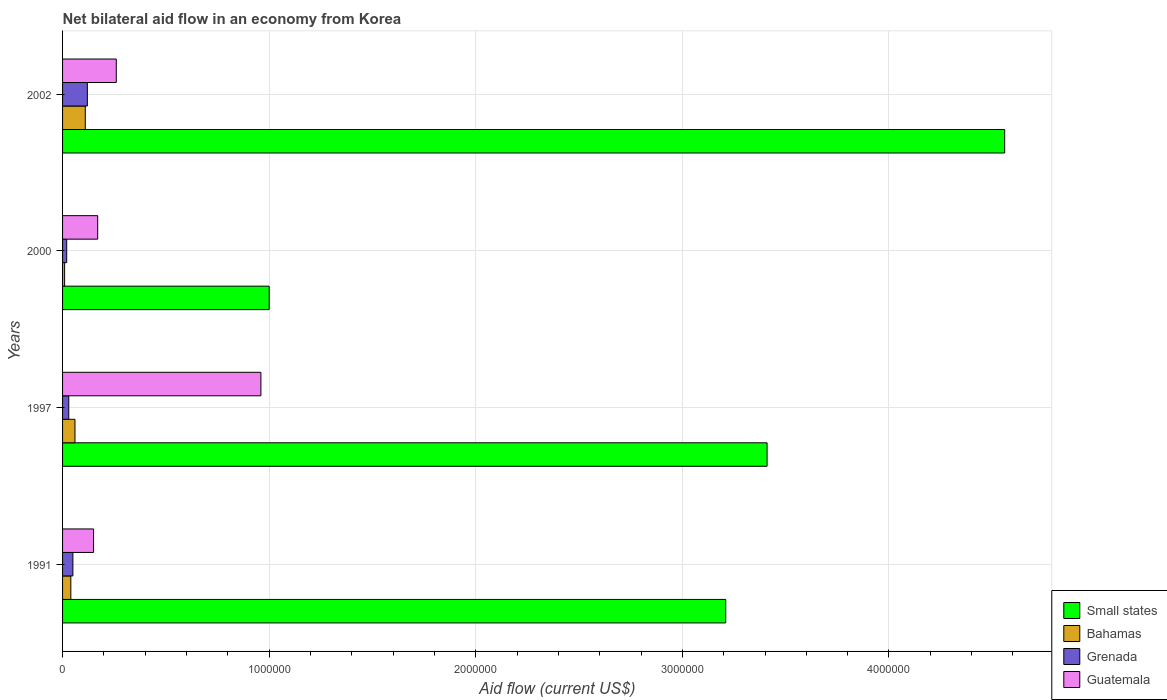How many different coloured bars are there?
Your response must be concise. 4. How many groups of bars are there?
Offer a very short reply. 4. Are the number of bars per tick equal to the number of legend labels?
Your answer should be very brief. Yes. In how many cases, is the number of bars for a given year not equal to the number of legend labels?
Your answer should be very brief. 0. Across all years, what is the maximum net bilateral aid flow in Guatemala?
Make the answer very short. 9.60e+05. In which year was the net bilateral aid flow in Guatemala maximum?
Offer a terse response. 1997. What is the total net bilateral aid flow in Guatemala in the graph?
Ensure brevity in your answer.  1.54e+06. What is the difference between the net bilateral aid flow in Guatemala in 2000 and that in 2002?
Keep it short and to the point. -9.00e+04. What is the difference between the net bilateral aid flow in Small states in 1997 and the net bilateral aid flow in Grenada in 2002?
Ensure brevity in your answer.  3.29e+06. What is the average net bilateral aid flow in Grenada per year?
Keep it short and to the point. 5.50e+04. In the year 2000, what is the difference between the net bilateral aid flow in Guatemala and net bilateral aid flow in Small states?
Keep it short and to the point. -8.30e+05. What is the ratio of the net bilateral aid flow in Small states in 1997 to that in 2000?
Provide a short and direct response. 3.41. What is the difference between the highest and the second highest net bilateral aid flow in Bahamas?
Offer a very short reply. 5.00e+04. What is the difference between the highest and the lowest net bilateral aid flow in Guatemala?
Your answer should be compact. 8.10e+05. Is the sum of the net bilateral aid flow in Grenada in 2000 and 2002 greater than the maximum net bilateral aid flow in Small states across all years?
Make the answer very short. No. What does the 4th bar from the top in 1991 represents?
Give a very brief answer. Small states. What does the 1st bar from the bottom in 1997 represents?
Offer a very short reply. Small states. Are all the bars in the graph horizontal?
Your answer should be very brief. Yes. How many years are there in the graph?
Offer a terse response. 4. What is the difference between two consecutive major ticks on the X-axis?
Ensure brevity in your answer.  1.00e+06. Are the values on the major ticks of X-axis written in scientific E-notation?
Provide a short and direct response. No. Does the graph contain grids?
Keep it short and to the point. Yes. Where does the legend appear in the graph?
Your answer should be compact. Bottom right. How many legend labels are there?
Keep it short and to the point. 4. How are the legend labels stacked?
Your answer should be compact. Vertical. What is the title of the graph?
Your answer should be compact. Net bilateral aid flow in an economy from Korea. What is the label or title of the Y-axis?
Give a very brief answer. Years. What is the Aid flow (current US$) in Small states in 1991?
Your response must be concise. 3.21e+06. What is the Aid flow (current US$) of Guatemala in 1991?
Keep it short and to the point. 1.50e+05. What is the Aid flow (current US$) of Small states in 1997?
Provide a short and direct response. 3.41e+06. What is the Aid flow (current US$) in Guatemala in 1997?
Provide a short and direct response. 9.60e+05. What is the Aid flow (current US$) of Small states in 2000?
Your answer should be very brief. 1.00e+06. What is the Aid flow (current US$) in Bahamas in 2000?
Keep it short and to the point. 10000. What is the Aid flow (current US$) of Guatemala in 2000?
Keep it short and to the point. 1.70e+05. What is the Aid flow (current US$) of Small states in 2002?
Provide a succinct answer. 4.56e+06. What is the Aid flow (current US$) in Grenada in 2002?
Provide a short and direct response. 1.20e+05. Across all years, what is the maximum Aid flow (current US$) of Small states?
Your response must be concise. 4.56e+06. Across all years, what is the maximum Aid flow (current US$) in Bahamas?
Ensure brevity in your answer.  1.10e+05. Across all years, what is the maximum Aid flow (current US$) of Guatemala?
Your answer should be very brief. 9.60e+05. Across all years, what is the minimum Aid flow (current US$) in Small states?
Provide a short and direct response. 1.00e+06. Across all years, what is the minimum Aid flow (current US$) of Bahamas?
Your response must be concise. 10000. Across all years, what is the minimum Aid flow (current US$) in Grenada?
Make the answer very short. 2.00e+04. Across all years, what is the minimum Aid flow (current US$) in Guatemala?
Keep it short and to the point. 1.50e+05. What is the total Aid flow (current US$) in Small states in the graph?
Provide a short and direct response. 1.22e+07. What is the total Aid flow (current US$) in Bahamas in the graph?
Your answer should be compact. 2.20e+05. What is the total Aid flow (current US$) in Grenada in the graph?
Make the answer very short. 2.20e+05. What is the total Aid flow (current US$) of Guatemala in the graph?
Make the answer very short. 1.54e+06. What is the difference between the Aid flow (current US$) of Bahamas in 1991 and that in 1997?
Provide a succinct answer. -2.00e+04. What is the difference between the Aid flow (current US$) of Grenada in 1991 and that in 1997?
Make the answer very short. 2.00e+04. What is the difference between the Aid flow (current US$) of Guatemala in 1991 and that in 1997?
Offer a terse response. -8.10e+05. What is the difference between the Aid flow (current US$) in Small states in 1991 and that in 2000?
Keep it short and to the point. 2.21e+06. What is the difference between the Aid flow (current US$) of Bahamas in 1991 and that in 2000?
Keep it short and to the point. 3.00e+04. What is the difference between the Aid flow (current US$) of Small states in 1991 and that in 2002?
Make the answer very short. -1.35e+06. What is the difference between the Aid flow (current US$) of Bahamas in 1991 and that in 2002?
Keep it short and to the point. -7.00e+04. What is the difference between the Aid flow (current US$) of Grenada in 1991 and that in 2002?
Give a very brief answer. -7.00e+04. What is the difference between the Aid flow (current US$) of Guatemala in 1991 and that in 2002?
Provide a short and direct response. -1.10e+05. What is the difference between the Aid flow (current US$) in Small states in 1997 and that in 2000?
Offer a terse response. 2.41e+06. What is the difference between the Aid flow (current US$) in Guatemala in 1997 and that in 2000?
Provide a short and direct response. 7.90e+05. What is the difference between the Aid flow (current US$) of Small states in 1997 and that in 2002?
Your answer should be very brief. -1.15e+06. What is the difference between the Aid flow (current US$) in Small states in 2000 and that in 2002?
Your answer should be very brief. -3.56e+06. What is the difference between the Aid flow (current US$) in Grenada in 2000 and that in 2002?
Provide a succinct answer. -1.00e+05. What is the difference between the Aid flow (current US$) of Guatemala in 2000 and that in 2002?
Your response must be concise. -9.00e+04. What is the difference between the Aid flow (current US$) in Small states in 1991 and the Aid flow (current US$) in Bahamas in 1997?
Keep it short and to the point. 3.15e+06. What is the difference between the Aid flow (current US$) in Small states in 1991 and the Aid flow (current US$) in Grenada in 1997?
Provide a succinct answer. 3.18e+06. What is the difference between the Aid flow (current US$) of Small states in 1991 and the Aid flow (current US$) of Guatemala in 1997?
Your response must be concise. 2.25e+06. What is the difference between the Aid flow (current US$) of Bahamas in 1991 and the Aid flow (current US$) of Grenada in 1997?
Make the answer very short. 10000. What is the difference between the Aid flow (current US$) of Bahamas in 1991 and the Aid flow (current US$) of Guatemala in 1997?
Your response must be concise. -9.20e+05. What is the difference between the Aid flow (current US$) in Grenada in 1991 and the Aid flow (current US$) in Guatemala in 1997?
Ensure brevity in your answer.  -9.10e+05. What is the difference between the Aid flow (current US$) in Small states in 1991 and the Aid flow (current US$) in Bahamas in 2000?
Your response must be concise. 3.20e+06. What is the difference between the Aid flow (current US$) in Small states in 1991 and the Aid flow (current US$) in Grenada in 2000?
Your response must be concise. 3.19e+06. What is the difference between the Aid flow (current US$) of Small states in 1991 and the Aid flow (current US$) of Guatemala in 2000?
Your response must be concise. 3.04e+06. What is the difference between the Aid flow (current US$) in Bahamas in 1991 and the Aid flow (current US$) in Grenada in 2000?
Provide a short and direct response. 2.00e+04. What is the difference between the Aid flow (current US$) in Grenada in 1991 and the Aid flow (current US$) in Guatemala in 2000?
Your answer should be compact. -1.20e+05. What is the difference between the Aid flow (current US$) in Small states in 1991 and the Aid flow (current US$) in Bahamas in 2002?
Offer a very short reply. 3.10e+06. What is the difference between the Aid flow (current US$) of Small states in 1991 and the Aid flow (current US$) of Grenada in 2002?
Your answer should be very brief. 3.09e+06. What is the difference between the Aid flow (current US$) in Small states in 1991 and the Aid flow (current US$) in Guatemala in 2002?
Your answer should be very brief. 2.95e+06. What is the difference between the Aid flow (current US$) in Bahamas in 1991 and the Aid flow (current US$) in Grenada in 2002?
Provide a short and direct response. -8.00e+04. What is the difference between the Aid flow (current US$) of Bahamas in 1991 and the Aid flow (current US$) of Guatemala in 2002?
Provide a succinct answer. -2.20e+05. What is the difference between the Aid flow (current US$) in Grenada in 1991 and the Aid flow (current US$) in Guatemala in 2002?
Make the answer very short. -2.10e+05. What is the difference between the Aid flow (current US$) in Small states in 1997 and the Aid flow (current US$) in Bahamas in 2000?
Offer a terse response. 3.40e+06. What is the difference between the Aid flow (current US$) of Small states in 1997 and the Aid flow (current US$) of Grenada in 2000?
Offer a terse response. 3.39e+06. What is the difference between the Aid flow (current US$) of Small states in 1997 and the Aid flow (current US$) of Guatemala in 2000?
Provide a short and direct response. 3.24e+06. What is the difference between the Aid flow (current US$) in Bahamas in 1997 and the Aid flow (current US$) in Grenada in 2000?
Make the answer very short. 4.00e+04. What is the difference between the Aid flow (current US$) in Bahamas in 1997 and the Aid flow (current US$) in Guatemala in 2000?
Your answer should be very brief. -1.10e+05. What is the difference between the Aid flow (current US$) of Small states in 1997 and the Aid flow (current US$) of Bahamas in 2002?
Keep it short and to the point. 3.30e+06. What is the difference between the Aid flow (current US$) of Small states in 1997 and the Aid flow (current US$) of Grenada in 2002?
Your answer should be very brief. 3.29e+06. What is the difference between the Aid flow (current US$) of Small states in 1997 and the Aid flow (current US$) of Guatemala in 2002?
Offer a terse response. 3.15e+06. What is the difference between the Aid flow (current US$) of Bahamas in 1997 and the Aid flow (current US$) of Grenada in 2002?
Your answer should be compact. -6.00e+04. What is the difference between the Aid flow (current US$) of Bahamas in 1997 and the Aid flow (current US$) of Guatemala in 2002?
Offer a very short reply. -2.00e+05. What is the difference between the Aid flow (current US$) in Small states in 2000 and the Aid flow (current US$) in Bahamas in 2002?
Your response must be concise. 8.90e+05. What is the difference between the Aid flow (current US$) in Small states in 2000 and the Aid flow (current US$) in Grenada in 2002?
Your answer should be compact. 8.80e+05. What is the difference between the Aid flow (current US$) of Small states in 2000 and the Aid flow (current US$) of Guatemala in 2002?
Make the answer very short. 7.40e+05. What is the difference between the Aid flow (current US$) of Bahamas in 2000 and the Aid flow (current US$) of Guatemala in 2002?
Provide a succinct answer. -2.50e+05. What is the average Aid flow (current US$) in Small states per year?
Your response must be concise. 3.04e+06. What is the average Aid flow (current US$) of Bahamas per year?
Offer a very short reply. 5.50e+04. What is the average Aid flow (current US$) of Grenada per year?
Your answer should be compact. 5.50e+04. What is the average Aid flow (current US$) of Guatemala per year?
Offer a very short reply. 3.85e+05. In the year 1991, what is the difference between the Aid flow (current US$) in Small states and Aid flow (current US$) in Bahamas?
Your answer should be very brief. 3.17e+06. In the year 1991, what is the difference between the Aid flow (current US$) in Small states and Aid flow (current US$) in Grenada?
Offer a very short reply. 3.16e+06. In the year 1991, what is the difference between the Aid flow (current US$) of Small states and Aid flow (current US$) of Guatemala?
Provide a short and direct response. 3.06e+06. In the year 1991, what is the difference between the Aid flow (current US$) in Bahamas and Aid flow (current US$) in Grenada?
Your answer should be compact. -10000. In the year 1997, what is the difference between the Aid flow (current US$) in Small states and Aid flow (current US$) in Bahamas?
Provide a succinct answer. 3.35e+06. In the year 1997, what is the difference between the Aid flow (current US$) in Small states and Aid flow (current US$) in Grenada?
Your answer should be compact. 3.38e+06. In the year 1997, what is the difference between the Aid flow (current US$) in Small states and Aid flow (current US$) in Guatemala?
Give a very brief answer. 2.45e+06. In the year 1997, what is the difference between the Aid flow (current US$) in Bahamas and Aid flow (current US$) in Grenada?
Your answer should be compact. 3.00e+04. In the year 1997, what is the difference between the Aid flow (current US$) of Bahamas and Aid flow (current US$) of Guatemala?
Offer a terse response. -9.00e+05. In the year 1997, what is the difference between the Aid flow (current US$) in Grenada and Aid flow (current US$) in Guatemala?
Provide a succinct answer. -9.30e+05. In the year 2000, what is the difference between the Aid flow (current US$) of Small states and Aid flow (current US$) of Bahamas?
Provide a short and direct response. 9.90e+05. In the year 2000, what is the difference between the Aid flow (current US$) of Small states and Aid flow (current US$) of Grenada?
Your answer should be very brief. 9.80e+05. In the year 2000, what is the difference between the Aid flow (current US$) in Small states and Aid flow (current US$) in Guatemala?
Make the answer very short. 8.30e+05. In the year 2000, what is the difference between the Aid flow (current US$) in Bahamas and Aid flow (current US$) in Grenada?
Your answer should be compact. -10000. In the year 2000, what is the difference between the Aid flow (current US$) in Bahamas and Aid flow (current US$) in Guatemala?
Provide a short and direct response. -1.60e+05. In the year 2002, what is the difference between the Aid flow (current US$) of Small states and Aid flow (current US$) of Bahamas?
Offer a terse response. 4.45e+06. In the year 2002, what is the difference between the Aid flow (current US$) in Small states and Aid flow (current US$) in Grenada?
Offer a terse response. 4.44e+06. In the year 2002, what is the difference between the Aid flow (current US$) of Small states and Aid flow (current US$) of Guatemala?
Provide a short and direct response. 4.30e+06. In the year 2002, what is the difference between the Aid flow (current US$) of Grenada and Aid flow (current US$) of Guatemala?
Keep it short and to the point. -1.40e+05. What is the ratio of the Aid flow (current US$) of Small states in 1991 to that in 1997?
Your response must be concise. 0.94. What is the ratio of the Aid flow (current US$) in Bahamas in 1991 to that in 1997?
Provide a succinct answer. 0.67. What is the ratio of the Aid flow (current US$) of Guatemala in 1991 to that in 1997?
Your response must be concise. 0.16. What is the ratio of the Aid flow (current US$) of Small states in 1991 to that in 2000?
Make the answer very short. 3.21. What is the ratio of the Aid flow (current US$) in Grenada in 1991 to that in 2000?
Make the answer very short. 2.5. What is the ratio of the Aid flow (current US$) in Guatemala in 1991 to that in 2000?
Provide a short and direct response. 0.88. What is the ratio of the Aid flow (current US$) in Small states in 1991 to that in 2002?
Ensure brevity in your answer.  0.7. What is the ratio of the Aid flow (current US$) of Bahamas in 1991 to that in 2002?
Your response must be concise. 0.36. What is the ratio of the Aid flow (current US$) in Grenada in 1991 to that in 2002?
Provide a short and direct response. 0.42. What is the ratio of the Aid flow (current US$) of Guatemala in 1991 to that in 2002?
Your answer should be compact. 0.58. What is the ratio of the Aid flow (current US$) in Small states in 1997 to that in 2000?
Keep it short and to the point. 3.41. What is the ratio of the Aid flow (current US$) of Bahamas in 1997 to that in 2000?
Give a very brief answer. 6. What is the ratio of the Aid flow (current US$) of Grenada in 1997 to that in 2000?
Provide a short and direct response. 1.5. What is the ratio of the Aid flow (current US$) of Guatemala in 1997 to that in 2000?
Offer a very short reply. 5.65. What is the ratio of the Aid flow (current US$) of Small states in 1997 to that in 2002?
Your response must be concise. 0.75. What is the ratio of the Aid flow (current US$) in Bahamas in 1997 to that in 2002?
Give a very brief answer. 0.55. What is the ratio of the Aid flow (current US$) in Guatemala in 1997 to that in 2002?
Your answer should be compact. 3.69. What is the ratio of the Aid flow (current US$) of Small states in 2000 to that in 2002?
Your response must be concise. 0.22. What is the ratio of the Aid flow (current US$) of Bahamas in 2000 to that in 2002?
Your response must be concise. 0.09. What is the ratio of the Aid flow (current US$) in Guatemala in 2000 to that in 2002?
Your response must be concise. 0.65. What is the difference between the highest and the second highest Aid flow (current US$) in Small states?
Keep it short and to the point. 1.15e+06. What is the difference between the highest and the second highest Aid flow (current US$) of Grenada?
Offer a very short reply. 7.00e+04. What is the difference between the highest and the second highest Aid flow (current US$) of Guatemala?
Your answer should be very brief. 7.00e+05. What is the difference between the highest and the lowest Aid flow (current US$) of Small states?
Your answer should be compact. 3.56e+06. What is the difference between the highest and the lowest Aid flow (current US$) of Bahamas?
Offer a terse response. 1.00e+05. What is the difference between the highest and the lowest Aid flow (current US$) of Guatemala?
Provide a succinct answer. 8.10e+05. 